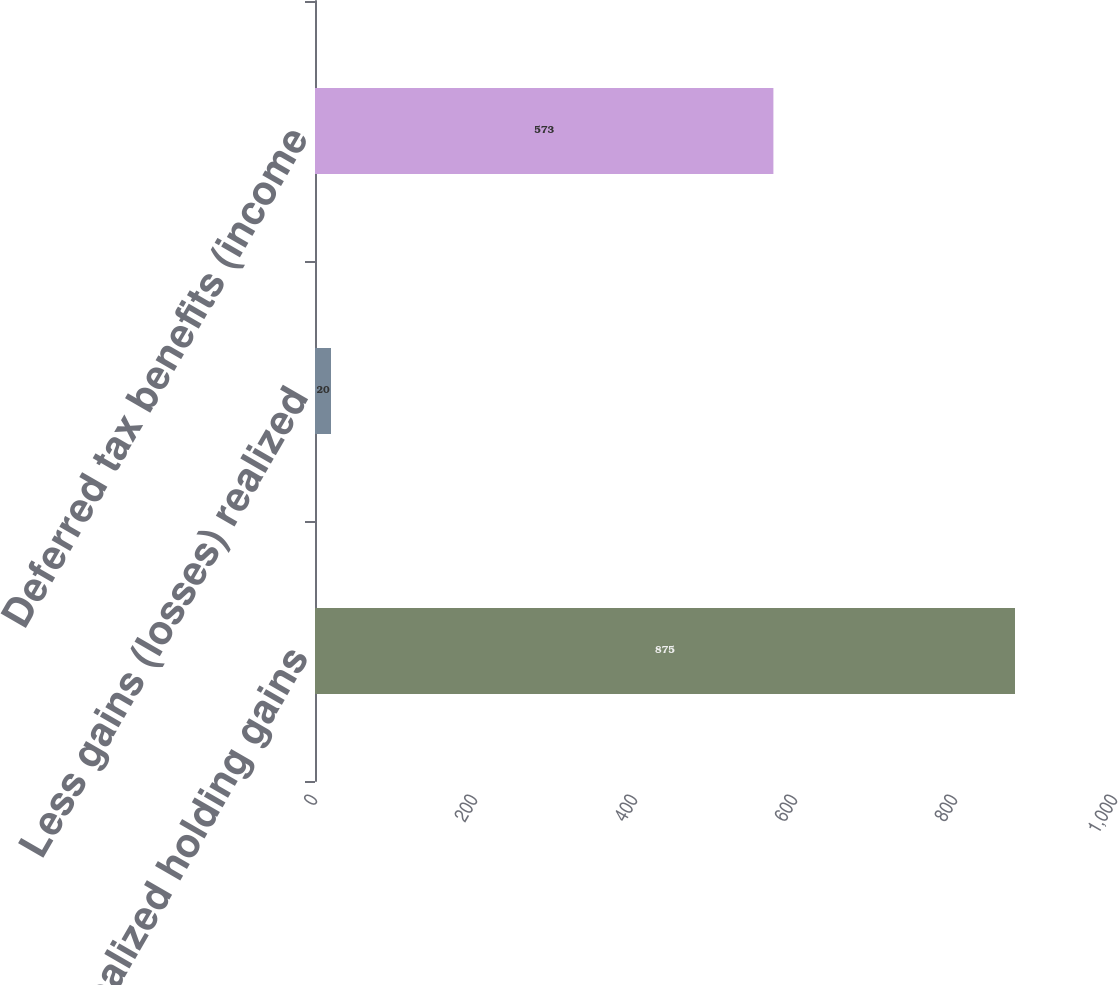Convert chart to OTSL. <chart><loc_0><loc_0><loc_500><loc_500><bar_chart><fcel>Unrealized holding gains<fcel>Less gains (losses) realized<fcel>Deferred tax benefits (income<nl><fcel>875<fcel>20<fcel>573<nl></chart> 